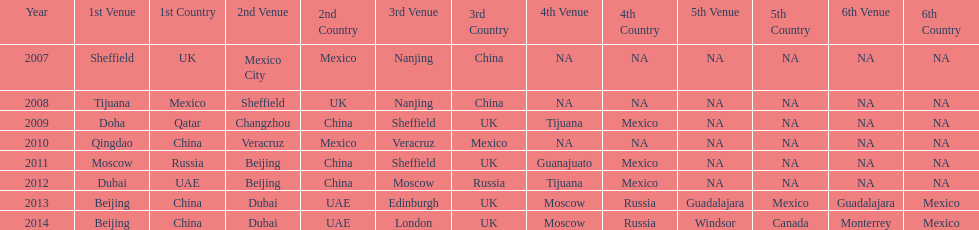Which year is previous to 2011 2010. 